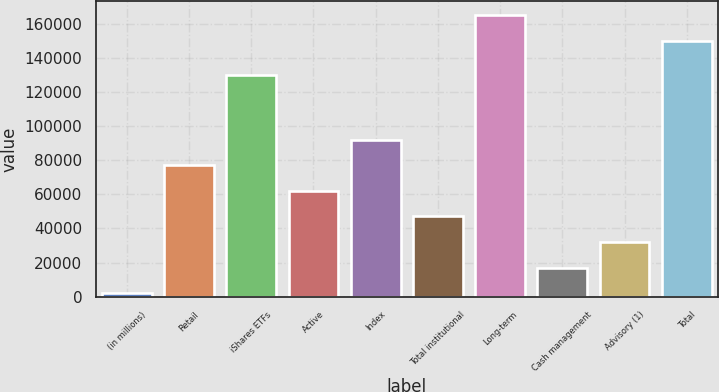Convert chart to OTSL. <chart><loc_0><loc_0><loc_500><loc_500><bar_chart><fcel>(in millions)<fcel>Retail<fcel>iShares ETFs<fcel>Active<fcel>Index<fcel>Total institutional<fcel>Long-term<fcel>Cash management<fcel>Advisory (1)<fcel>Total<nl><fcel>2015<fcel>77014.5<fcel>129852<fcel>62014.6<fcel>92014.4<fcel>47014.7<fcel>164895<fcel>17014.9<fcel>32014.8<fcel>149895<nl></chart> 